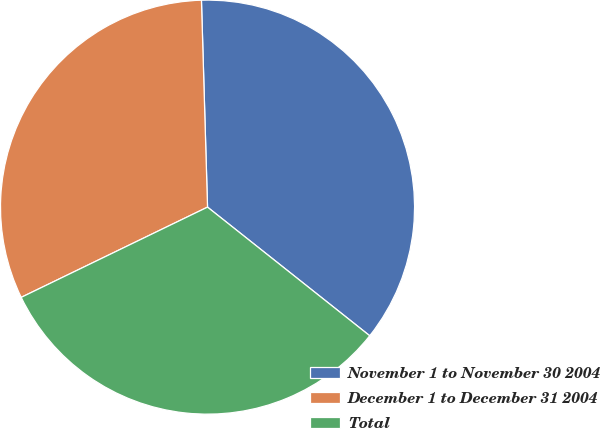Convert chart to OTSL. <chart><loc_0><loc_0><loc_500><loc_500><pie_chart><fcel>November 1 to November 30 2004<fcel>December 1 to December 31 2004<fcel>Total<nl><fcel>36.14%<fcel>31.71%<fcel>32.15%<nl></chart> 